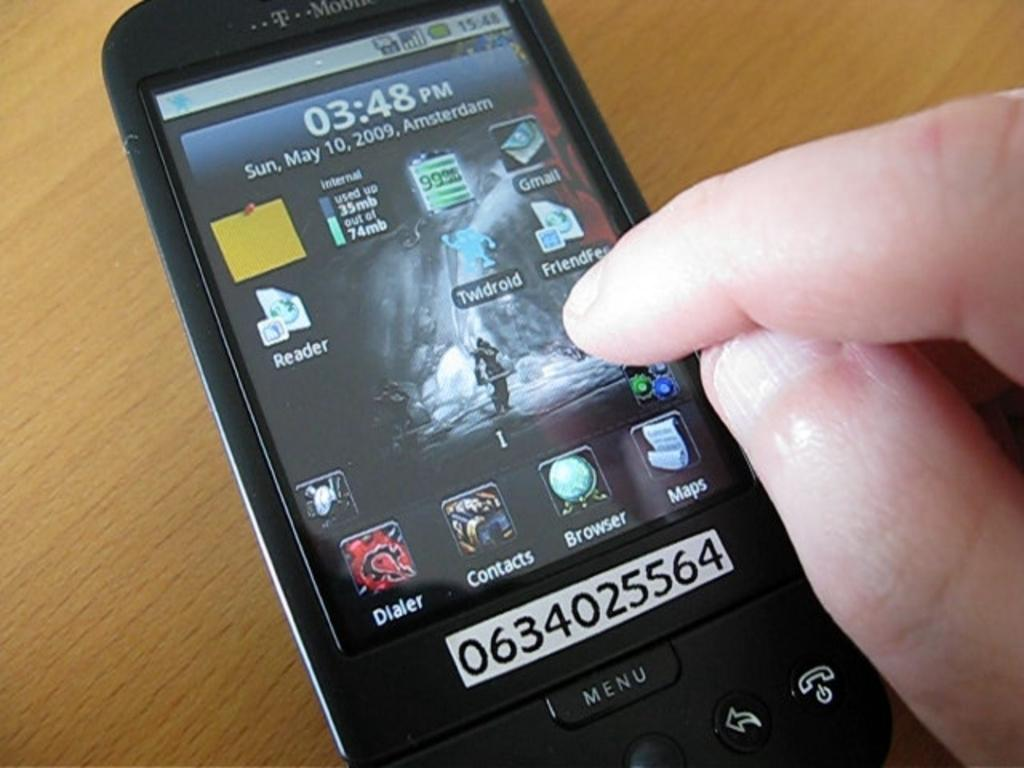<image>
Write a terse but informative summary of the picture. The phone on the table is a T mobile phone. 